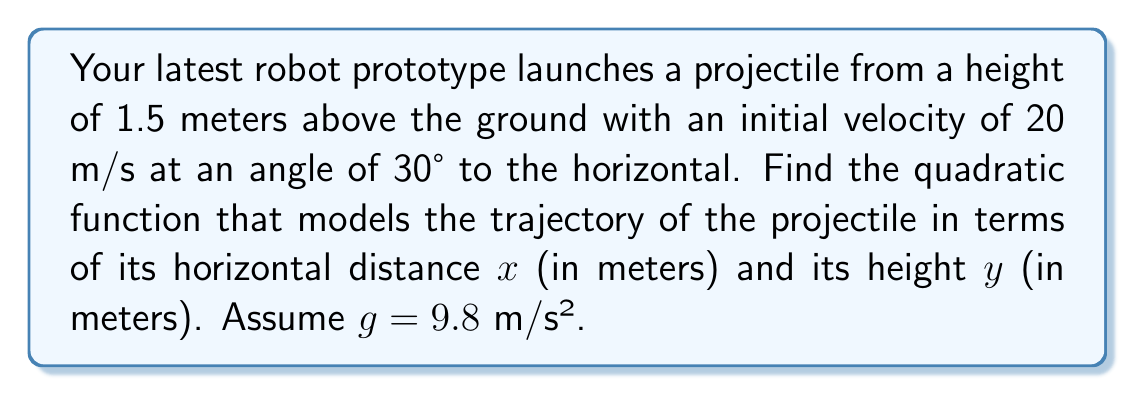What is the answer to this math problem? To find the quadratic function modeling the projectile's trajectory, we'll follow these steps:

1) The general form of a projectile motion equation is:
   $$y = -\frac{1}{2}g(\frac{x}{v_x})^2 + (\tan \theta)x + h$$
   where g is acceleration due to gravity, $v_x$ is horizontal velocity, θ is launch angle, and h is initial height.

2) Calculate $v_x$:
   $v_x = v \cos \theta = 20 \cos 30° = 20 \cdot \frac{\sqrt{3}}{2} = 10\sqrt{3}$ m/s

3) Calculate $\tan \theta$:
   $\tan 30° = \frac{1}{\sqrt{3}}$

4) Substitute these values into the general equation:
   $$y = -\frac{1}{2}(9.8)(\frac{x}{10\sqrt{3}})^2 + (\frac{1}{\sqrt{3}})x + 1.5$$

5) Simplify:
   $$y = -\frac{9.8}{200\cdot3}x^2 + \frac{1}{\sqrt{3}}x + 1.5$$
   $$y = -\frac{49}{3000}x^2 + \frac{1}{\sqrt{3}}x + 1.5$$

This is the quadratic function modeling the projectile's trajectory.
Answer: $y = -\frac{49}{3000}x^2 + \frac{1}{\sqrt{3}}x + 1.5$ 